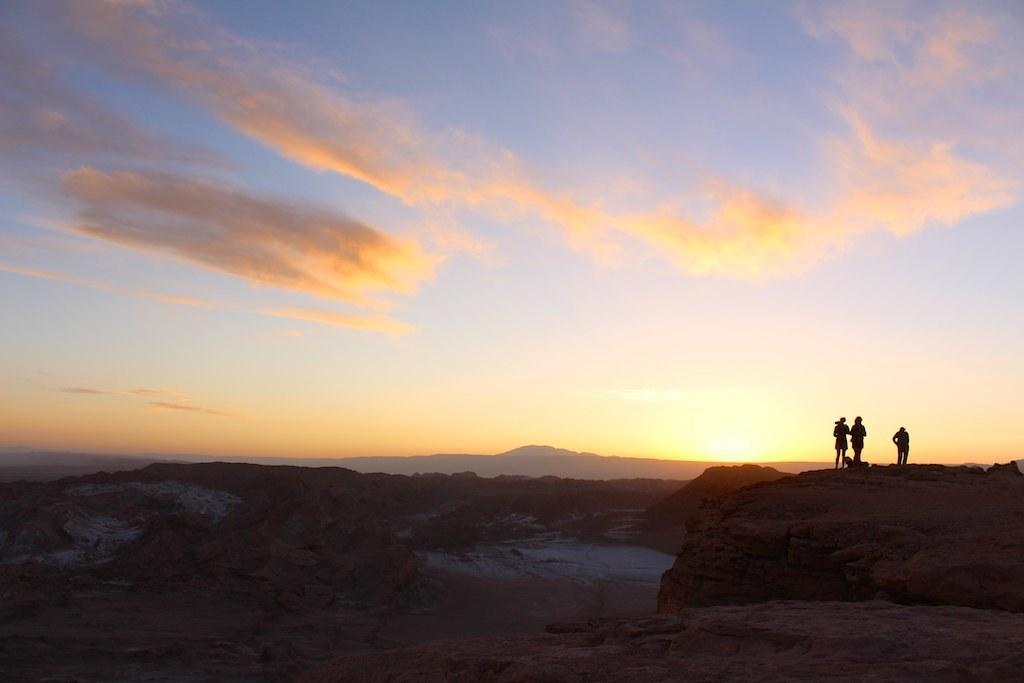Describe this image in one or two sentences. In this image we can see there are three persons standing on the rocks. In the background there is a sky. 